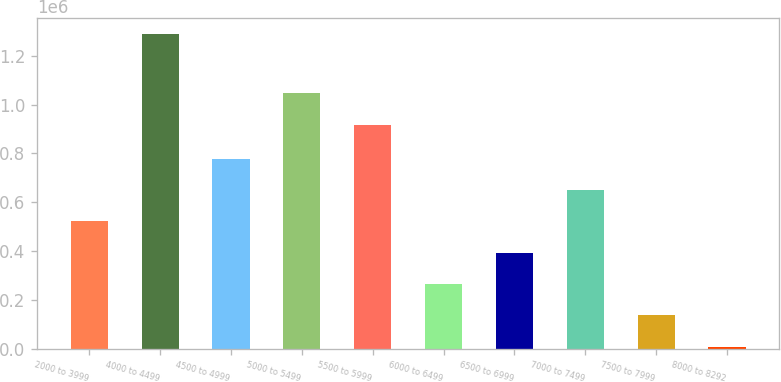Convert chart to OTSL. <chart><loc_0><loc_0><loc_500><loc_500><bar_chart><fcel>2000 to 3999<fcel>4000 to 4499<fcel>4500 to 4999<fcel>5000 to 5499<fcel>5500 to 5999<fcel>6000 to 6499<fcel>6500 to 6999<fcel>7000 to 7499<fcel>7500 to 7999<fcel>8000 to 8292<nl><fcel>521497<fcel>1.29024e+06<fcel>777746<fcel>1.04571e+06<fcel>917585<fcel>265249<fcel>393373<fcel>649622<fcel>137124<fcel>9000<nl></chart> 